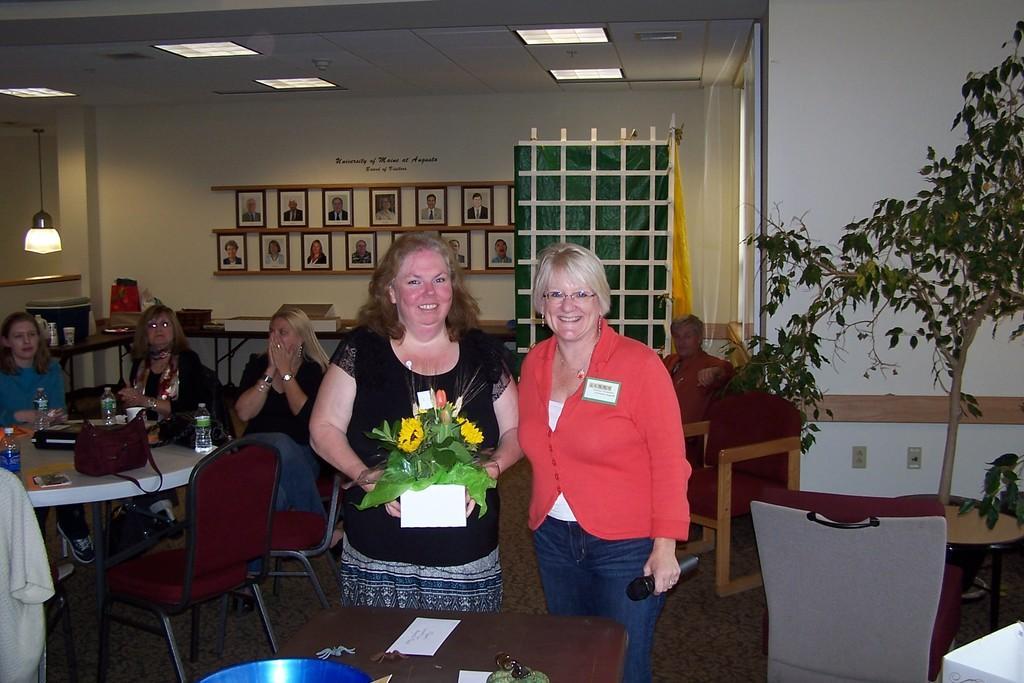How would you summarize this image in a sentence or two? In this picture we can see a women holding a flower bouquet, on his right side another women wearing a white dress and holding a mic. On the left side there are three women sitting on a chair. On a table we can see some water bottles, purse, files and mobile. On the right side we can see a tree. On the background there are photo-frames on the wall. A person sitting on sofa. 